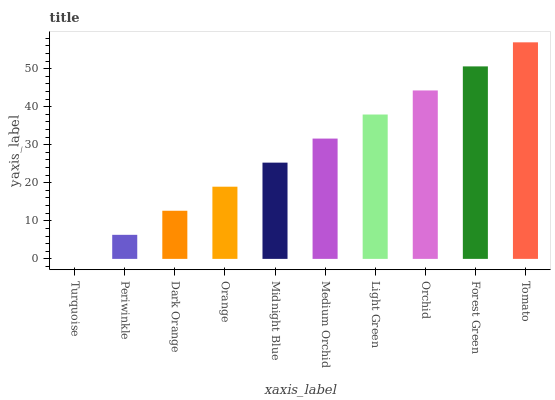Is Turquoise the minimum?
Answer yes or no. Yes. Is Tomato the maximum?
Answer yes or no. Yes. Is Periwinkle the minimum?
Answer yes or no. No. Is Periwinkle the maximum?
Answer yes or no. No. Is Periwinkle greater than Turquoise?
Answer yes or no. Yes. Is Turquoise less than Periwinkle?
Answer yes or no. Yes. Is Turquoise greater than Periwinkle?
Answer yes or no. No. Is Periwinkle less than Turquoise?
Answer yes or no. No. Is Medium Orchid the high median?
Answer yes or no. Yes. Is Midnight Blue the low median?
Answer yes or no. Yes. Is Tomato the high median?
Answer yes or no. No. Is Tomato the low median?
Answer yes or no. No. 